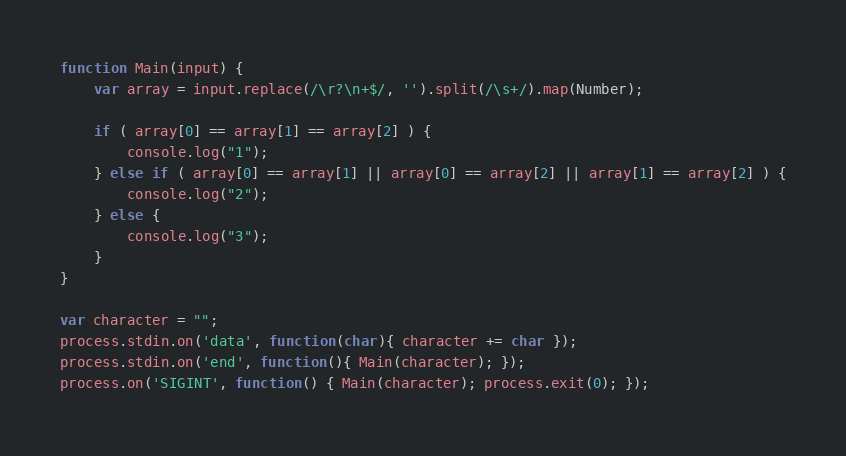<code> <loc_0><loc_0><loc_500><loc_500><_JavaScript_>function Main(input) {
    var array = input.replace(/\r?\n+$/, '').split(/\s+/).map(Number);

    if ( array[0] == array[1] == array[2] ) {
        console.log("1");
    } else if ( array[0] == array[1] || array[0] == array[2] || array[1] == array[2] ) {
        console.log("2");
    } else {
        console.log("3");
    }
}

var character = "";
process.stdin.on('data', function(char){ character += char });
process.stdin.on('end', function(){ Main(character); });
process.on('SIGINT', function() { Main(character); process.exit(0); });</code> 